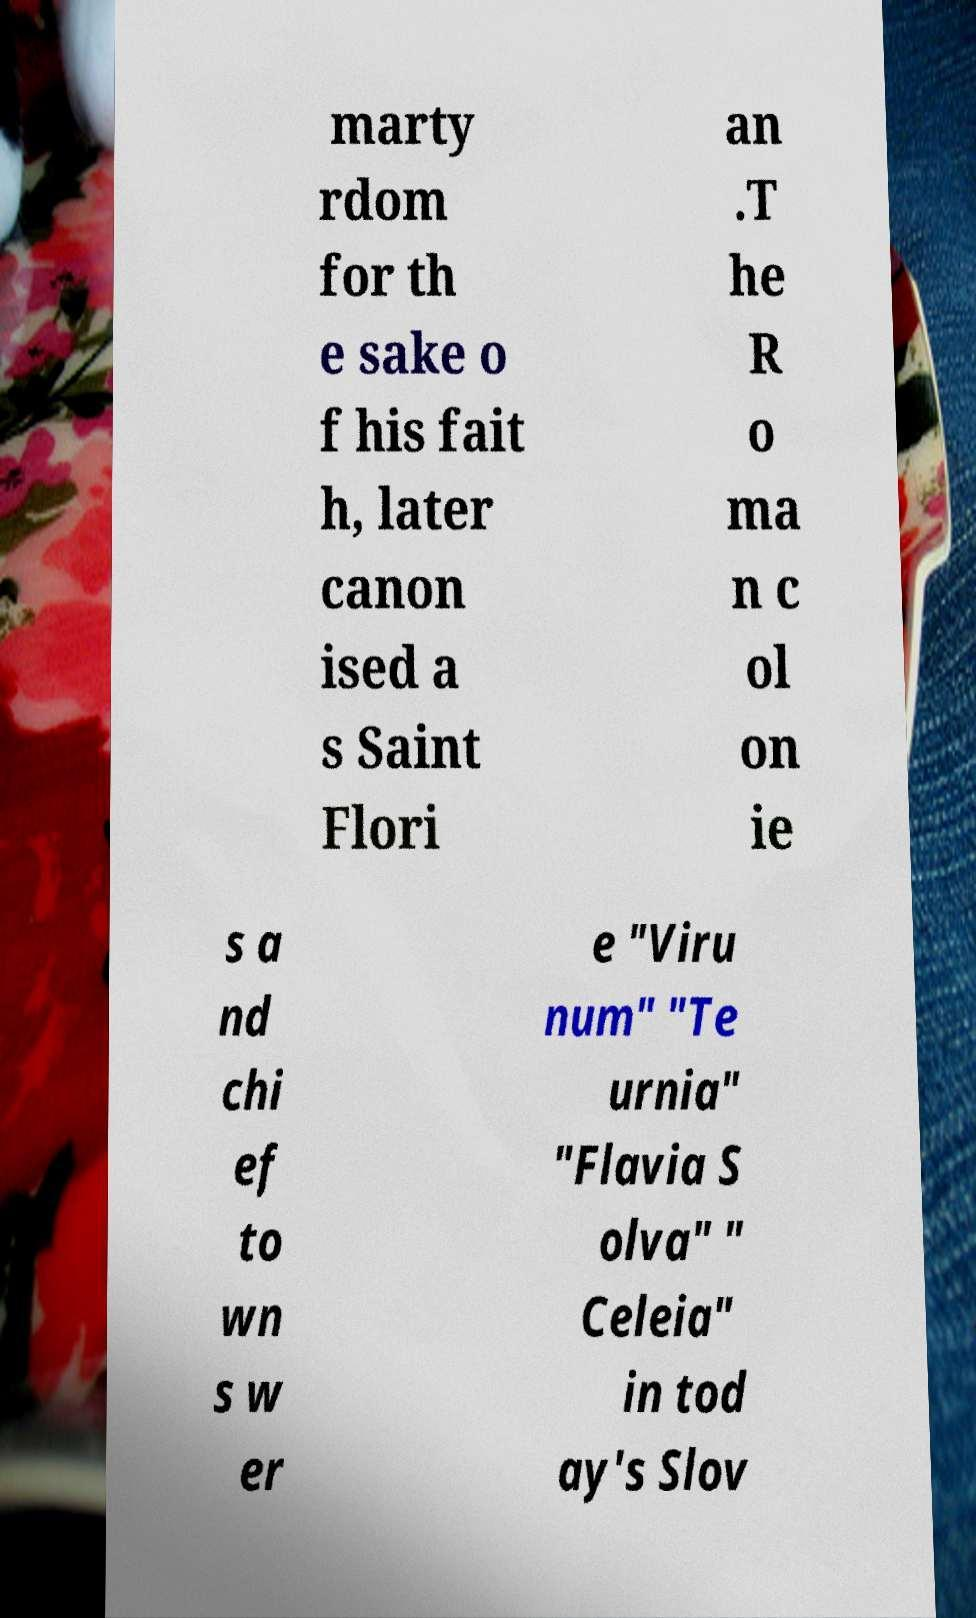I need the written content from this picture converted into text. Can you do that? marty rdom for th e sake o f his fait h, later canon ised a s Saint Flori an .T he R o ma n c ol on ie s a nd chi ef to wn s w er e "Viru num" "Te urnia" "Flavia S olva" " Celeia" in tod ay's Slov 